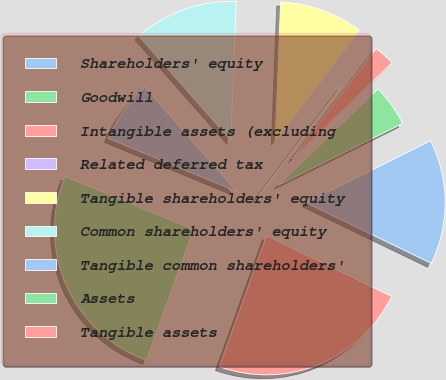Convert chart. <chart><loc_0><loc_0><loc_500><loc_500><pie_chart><fcel>Shareholders' equity<fcel>Goodwill<fcel>Intangible assets (excluding<fcel>Related deferred tax<fcel>Tangible shareholders' equity<fcel>Common shareholders' equity<fcel>Tangible common shareholders'<fcel>Assets<fcel>Tangible assets<nl><fcel>14.52%<fcel>4.86%<fcel>2.45%<fcel>0.03%<fcel>9.69%<fcel>12.11%<fcel>7.28%<fcel>25.74%<fcel>23.32%<nl></chart> 